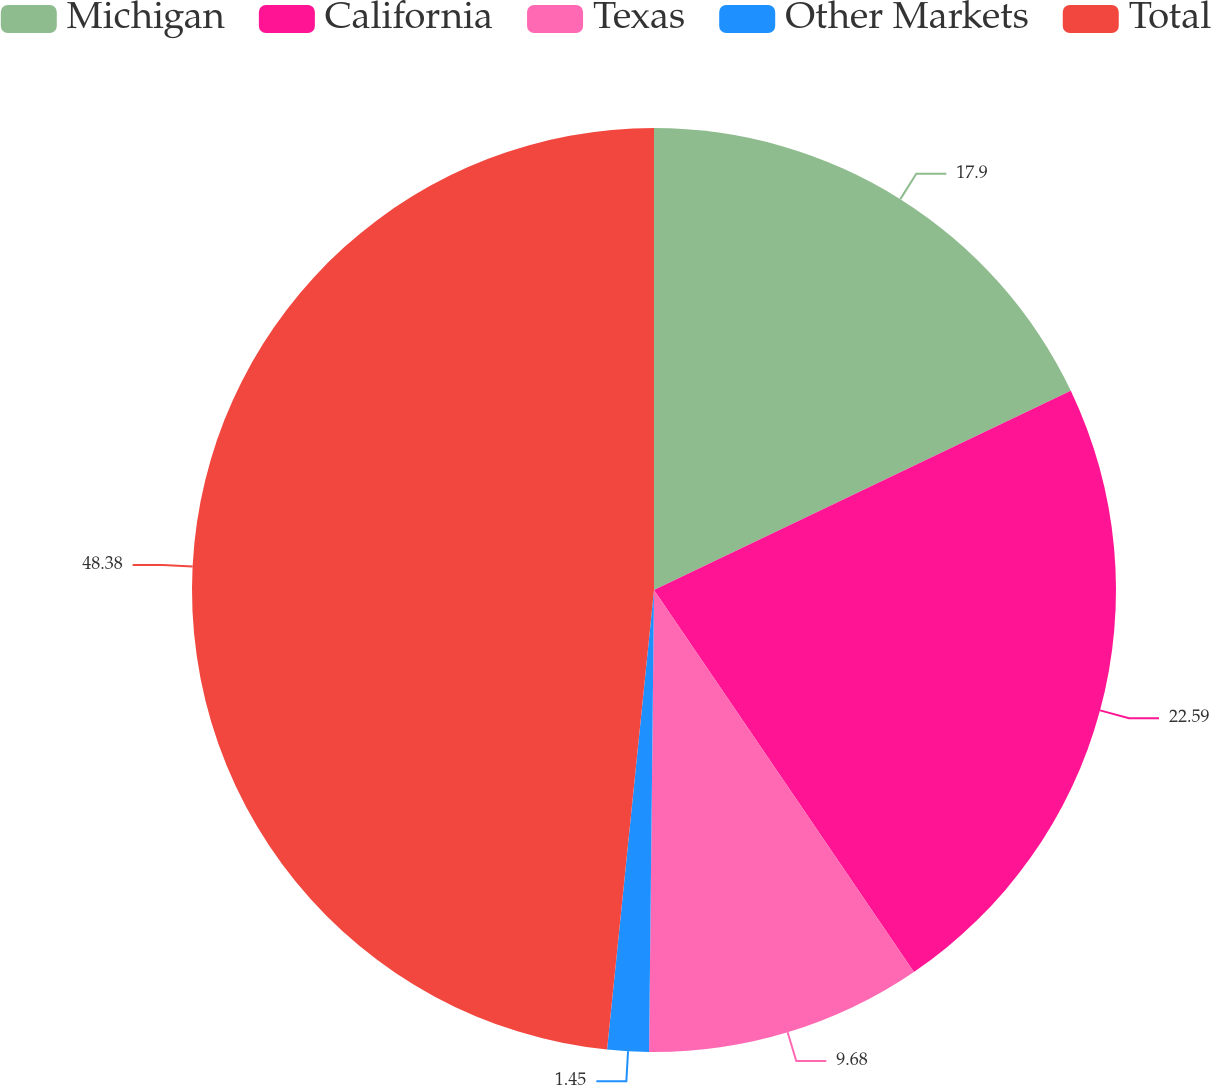<chart> <loc_0><loc_0><loc_500><loc_500><pie_chart><fcel>Michigan<fcel>California<fcel>Texas<fcel>Other Markets<fcel>Total<nl><fcel>17.9%<fcel>22.59%<fcel>9.68%<fcel>1.45%<fcel>48.38%<nl></chart> 